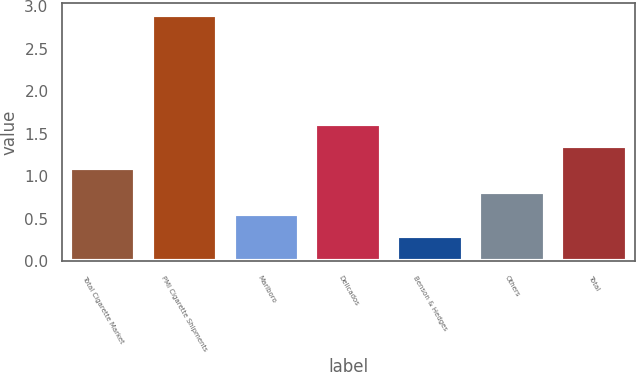<chart> <loc_0><loc_0><loc_500><loc_500><bar_chart><fcel>Total Cigarette Market<fcel>PMI Cigarette Shipments<fcel>Marlboro<fcel>Delicados<fcel>Benson & Hedges<fcel>Others<fcel>Total<nl><fcel>1.1<fcel>2.9<fcel>0.56<fcel>1.62<fcel>0.3<fcel>0.82<fcel>1.36<nl></chart> 